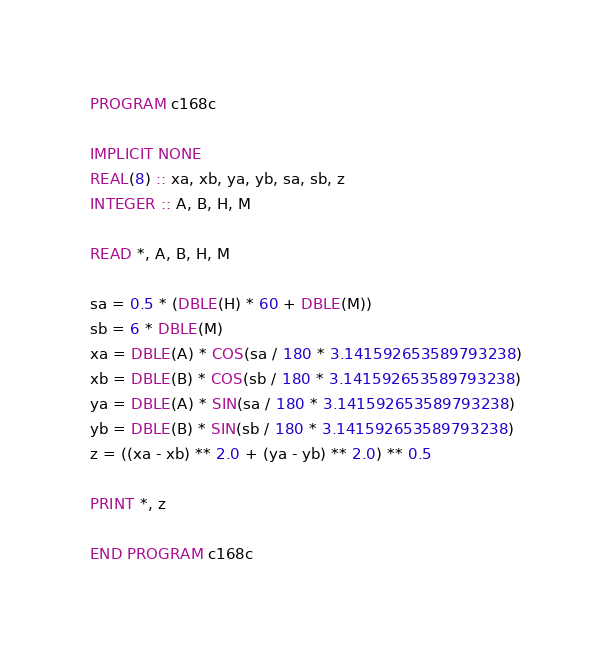<code> <loc_0><loc_0><loc_500><loc_500><_FORTRAN_>PROGRAM c168c

IMPLICIT NONE
REAL(8) :: xa, xb, ya, yb, sa, sb, z
INTEGER :: A, B, H, M

READ *, A, B, H, M

sa = 0.5 * (DBLE(H) * 60 + DBLE(M))
sb = 6 * DBLE(M)
xa = DBLE(A) * COS(sa / 180 * 3.141592653589793238)
xb = DBLE(B) * COS(sb / 180 * 3.141592653589793238)
ya = DBLE(A) * SIN(sa / 180 * 3.141592653589793238)
yb = DBLE(B) * SIN(sb / 180 * 3.141592653589793238)
z = ((xa - xb) ** 2.0 + (ya - yb) ** 2.0) ** 0.5

PRINT *, z

END PROGRAM c168c</code> 